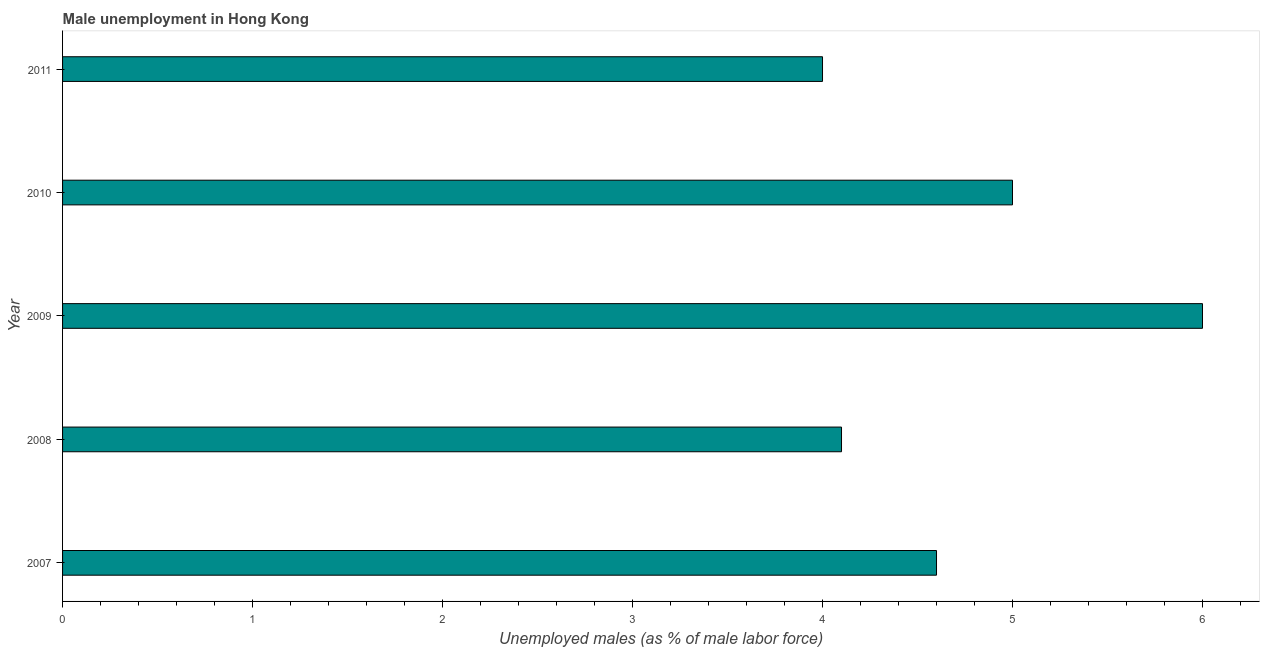What is the title of the graph?
Provide a succinct answer. Male unemployment in Hong Kong. What is the label or title of the X-axis?
Offer a very short reply. Unemployed males (as % of male labor force). What is the unemployed males population in 2011?
Offer a very short reply. 4. Across all years, what is the maximum unemployed males population?
Your response must be concise. 6. Across all years, what is the minimum unemployed males population?
Give a very brief answer. 4. What is the sum of the unemployed males population?
Make the answer very short. 23.7. What is the difference between the unemployed males population in 2008 and 2009?
Your response must be concise. -1.9. What is the average unemployed males population per year?
Give a very brief answer. 4.74. What is the median unemployed males population?
Your answer should be very brief. 4.6. Is the unemployed males population in 2009 less than that in 2011?
Keep it short and to the point. No. Is the sum of the unemployed males population in 2007 and 2011 greater than the maximum unemployed males population across all years?
Your answer should be very brief. Yes. In how many years, is the unemployed males population greater than the average unemployed males population taken over all years?
Ensure brevity in your answer.  2. How many bars are there?
Provide a short and direct response. 5. Are all the bars in the graph horizontal?
Ensure brevity in your answer.  Yes. How many years are there in the graph?
Give a very brief answer. 5. What is the Unemployed males (as % of male labor force) of 2007?
Provide a short and direct response. 4.6. What is the Unemployed males (as % of male labor force) in 2008?
Offer a very short reply. 4.1. What is the Unemployed males (as % of male labor force) in 2009?
Your answer should be compact. 6. What is the Unemployed males (as % of male labor force) in 2010?
Make the answer very short. 5. What is the difference between the Unemployed males (as % of male labor force) in 2007 and 2011?
Provide a succinct answer. 0.6. What is the difference between the Unemployed males (as % of male labor force) in 2008 and 2009?
Make the answer very short. -1.9. What is the difference between the Unemployed males (as % of male labor force) in 2008 and 2011?
Ensure brevity in your answer.  0.1. What is the difference between the Unemployed males (as % of male labor force) in 2009 and 2011?
Keep it short and to the point. 2. What is the ratio of the Unemployed males (as % of male labor force) in 2007 to that in 2008?
Give a very brief answer. 1.12. What is the ratio of the Unemployed males (as % of male labor force) in 2007 to that in 2009?
Your response must be concise. 0.77. What is the ratio of the Unemployed males (as % of male labor force) in 2007 to that in 2010?
Keep it short and to the point. 0.92. What is the ratio of the Unemployed males (as % of male labor force) in 2007 to that in 2011?
Offer a very short reply. 1.15. What is the ratio of the Unemployed males (as % of male labor force) in 2008 to that in 2009?
Give a very brief answer. 0.68. What is the ratio of the Unemployed males (as % of male labor force) in 2008 to that in 2010?
Provide a short and direct response. 0.82. What is the ratio of the Unemployed males (as % of male labor force) in 2009 to that in 2010?
Provide a short and direct response. 1.2. What is the ratio of the Unemployed males (as % of male labor force) in 2009 to that in 2011?
Provide a short and direct response. 1.5. What is the ratio of the Unemployed males (as % of male labor force) in 2010 to that in 2011?
Ensure brevity in your answer.  1.25. 